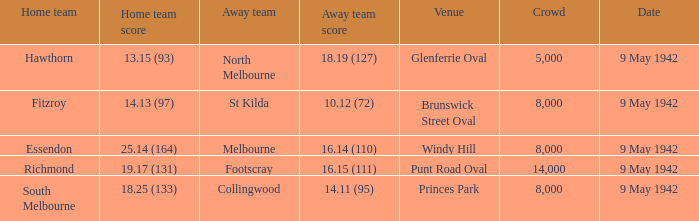What was the size of the crowd when the home team scored 1 8000.0. 